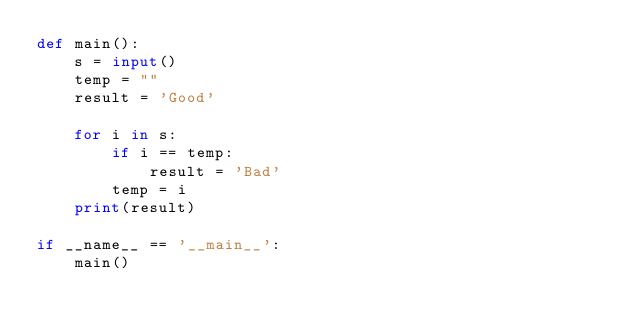<code> <loc_0><loc_0><loc_500><loc_500><_Python_>def main():
    s = input()
    temp = ""
    result = 'Good'

    for i in s:
        if i == temp:
            result = 'Bad'
        temp = i
    print(result)

if __name__ == '__main__':
    main()
</code> 